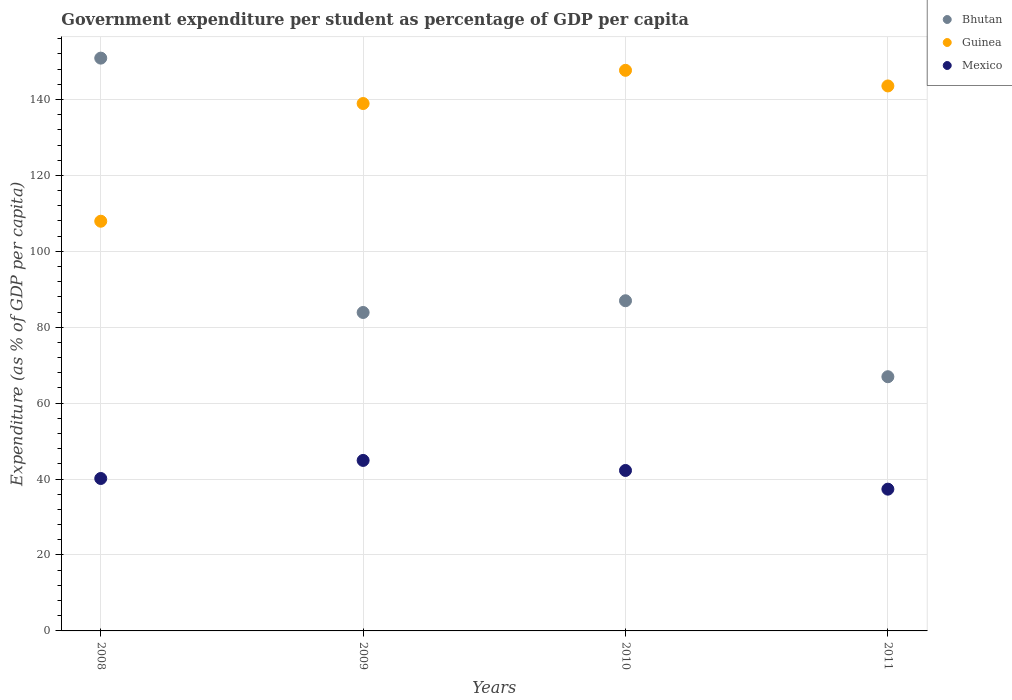How many different coloured dotlines are there?
Keep it short and to the point. 3. Is the number of dotlines equal to the number of legend labels?
Offer a very short reply. Yes. What is the percentage of expenditure per student in Mexico in 2009?
Your answer should be compact. 44.91. Across all years, what is the maximum percentage of expenditure per student in Mexico?
Offer a terse response. 44.91. Across all years, what is the minimum percentage of expenditure per student in Mexico?
Provide a short and direct response. 37.34. In which year was the percentage of expenditure per student in Mexico maximum?
Ensure brevity in your answer.  2009. In which year was the percentage of expenditure per student in Guinea minimum?
Your answer should be compact. 2008. What is the total percentage of expenditure per student in Mexico in the graph?
Keep it short and to the point. 164.68. What is the difference between the percentage of expenditure per student in Mexico in 2010 and that in 2011?
Your response must be concise. 4.92. What is the difference between the percentage of expenditure per student in Mexico in 2008 and the percentage of expenditure per student in Bhutan in 2009?
Keep it short and to the point. -43.73. What is the average percentage of expenditure per student in Bhutan per year?
Offer a very short reply. 97.18. In the year 2009, what is the difference between the percentage of expenditure per student in Bhutan and percentage of expenditure per student in Mexico?
Offer a terse response. 38.97. What is the ratio of the percentage of expenditure per student in Bhutan in 2009 to that in 2010?
Ensure brevity in your answer.  0.96. Is the difference between the percentage of expenditure per student in Bhutan in 2009 and 2010 greater than the difference between the percentage of expenditure per student in Mexico in 2009 and 2010?
Keep it short and to the point. No. What is the difference between the highest and the second highest percentage of expenditure per student in Bhutan?
Offer a terse response. 63.91. What is the difference between the highest and the lowest percentage of expenditure per student in Bhutan?
Offer a terse response. 83.93. Is the percentage of expenditure per student in Bhutan strictly greater than the percentage of expenditure per student in Guinea over the years?
Give a very brief answer. No. Is the percentage of expenditure per student in Bhutan strictly less than the percentage of expenditure per student in Guinea over the years?
Your answer should be very brief. No. How many years are there in the graph?
Your response must be concise. 4. What is the difference between two consecutive major ticks on the Y-axis?
Your response must be concise. 20. Are the values on the major ticks of Y-axis written in scientific E-notation?
Ensure brevity in your answer.  No. How are the legend labels stacked?
Make the answer very short. Vertical. What is the title of the graph?
Offer a terse response. Government expenditure per student as percentage of GDP per capita. Does "Sweden" appear as one of the legend labels in the graph?
Offer a terse response. No. What is the label or title of the X-axis?
Your answer should be very brief. Years. What is the label or title of the Y-axis?
Offer a very short reply. Expenditure (as % of GDP per capita). What is the Expenditure (as % of GDP per capita) in Bhutan in 2008?
Your response must be concise. 150.89. What is the Expenditure (as % of GDP per capita) of Guinea in 2008?
Offer a terse response. 107.93. What is the Expenditure (as % of GDP per capita) in Mexico in 2008?
Your answer should be very brief. 40.16. What is the Expenditure (as % of GDP per capita) in Bhutan in 2009?
Offer a very short reply. 83.89. What is the Expenditure (as % of GDP per capita) in Guinea in 2009?
Make the answer very short. 138.93. What is the Expenditure (as % of GDP per capita) in Mexico in 2009?
Offer a terse response. 44.91. What is the Expenditure (as % of GDP per capita) of Bhutan in 2010?
Offer a very short reply. 86.98. What is the Expenditure (as % of GDP per capita) of Guinea in 2010?
Offer a terse response. 147.68. What is the Expenditure (as % of GDP per capita) of Mexico in 2010?
Give a very brief answer. 42.27. What is the Expenditure (as % of GDP per capita) in Bhutan in 2011?
Keep it short and to the point. 66.96. What is the Expenditure (as % of GDP per capita) in Guinea in 2011?
Keep it short and to the point. 143.56. What is the Expenditure (as % of GDP per capita) in Mexico in 2011?
Give a very brief answer. 37.34. Across all years, what is the maximum Expenditure (as % of GDP per capita) of Bhutan?
Give a very brief answer. 150.89. Across all years, what is the maximum Expenditure (as % of GDP per capita) in Guinea?
Your answer should be very brief. 147.68. Across all years, what is the maximum Expenditure (as % of GDP per capita) of Mexico?
Your answer should be compact. 44.91. Across all years, what is the minimum Expenditure (as % of GDP per capita) of Bhutan?
Make the answer very short. 66.96. Across all years, what is the minimum Expenditure (as % of GDP per capita) in Guinea?
Your response must be concise. 107.93. Across all years, what is the minimum Expenditure (as % of GDP per capita) of Mexico?
Your response must be concise. 37.34. What is the total Expenditure (as % of GDP per capita) in Bhutan in the graph?
Give a very brief answer. 388.72. What is the total Expenditure (as % of GDP per capita) in Guinea in the graph?
Your response must be concise. 538.1. What is the total Expenditure (as % of GDP per capita) of Mexico in the graph?
Your response must be concise. 164.68. What is the difference between the Expenditure (as % of GDP per capita) in Bhutan in 2008 and that in 2009?
Your answer should be compact. 67. What is the difference between the Expenditure (as % of GDP per capita) of Guinea in 2008 and that in 2009?
Your answer should be very brief. -31.01. What is the difference between the Expenditure (as % of GDP per capita) of Mexico in 2008 and that in 2009?
Provide a succinct answer. -4.76. What is the difference between the Expenditure (as % of GDP per capita) of Bhutan in 2008 and that in 2010?
Ensure brevity in your answer.  63.91. What is the difference between the Expenditure (as % of GDP per capita) in Guinea in 2008 and that in 2010?
Your answer should be compact. -39.75. What is the difference between the Expenditure (as % of GDP per capita) of Mexico in 2008 and that in 2010?
Give a very brief answer. -2.11. What is the difference between the Expenditure (as % of GDP per capita) in Bhutan in 2008 and that in 2011?
Give a very brief answer. 83.93. What is the difference between the Expenditure (as % of GDP per capita) of Guinea in 2008 and that in 2011?
Offer a terse response. -35.64. What is the difference between the Expenditure (as % of GDP per capita) in Mexico in 2008 and that in 2011?
Make the answer very short. 2.81. What is the difference between the Expenditure (as % of GDP per capita) of Bhutan in 2009 and that in 2010?
Make the answer very short. -3.09. What is the difference between the Expenditure (as % of GDP per capita) in Guinea in 2009 and that in 2010?
Your answer should be compact. -8.74. What is the difference between the Expenditure (as % of GDP per capita) of Mexico in 2009 and that in 2010?
Your answer should be very brief. 2.65. What is the difference between the Expenditure (as % of GDP per capita) of Bhutan in 2009 and that in 2011?
Your answer should be very brief. 16.92. What is the difference between the Expenditure (as % of GDP per capita) in Guinea in 2009 and that in 2011?
Ensure brevity in your answer.  -4.63. What is the difference between the Expenditure (as % of GDP per capita) in Mexico in 2009 and that in 2011?
Your answer should be very brief. 7.57. What is the difference between the Expenditure (as % of GDP per capita) in Bhutan in 2010 and that in 2011?
Make the answer very short. 20.01. What is the difference between the Expenditure (as % of GDP per capita) in Guinea in 2010 and that in 2011?
Provide a succinct answer. 4.11. What is the difference between the Expenditure (as % of GDP per capita) of Mexico in 2010 and that in 2011?
Make the answer very short. 4.92. What is the difference between the Expenditure (as % of GDP per capita) in Bhutan in 2008 and the Expenditure (as % of GDP per capita) in Guinea in 2009?
Provide a short and direct response. 11.96. What is the difference between the Expenditure (as % of GDP per capita) of Bhutan in 2008 and the Expenditure (as % of GDP per capita) of Mexico in 2009?
Provide a succinct answer. 105.97. What is the difference between the Expenditure (as % of GDP per capita) of Guinea in 2008 and the Expenditure (as % of GDP per capita) of Mexico in 2009?
Give a very brief answer. 63.01. What is the difference between the Expenditure (as % of GDP per capita) of Bhutan in 2008 and the Expenditure (as % of GDP per capita) of Guinea in 2010?
Your answer should be compact. 3.21. What is the difference between the Expenditure (as % of GDP per capita) of Bhutan in 2008 and the Expenditure (as % of GDP per capita) of Mexico in 2010?
Offer a very short reply. 108.62. What is the difference between the Expenditure (as % of GDP per capita) of Guinea in 2008 and the Expenditure (as % of GDP per capita) of Mexico in 2010?
Give a very brief answer. 65.66. What is the difference between the Expenditure (as % of GDP per capita) in Bhutan in 2008 and the Expenditure (as % of GDP per capita) in Guinea in 2011?
Your response must be concise. 7.33. What is the difference between the Expenditure (as % of GDP per capita) in Bhutan in 2008 and the Expenditure (as % of GDP per capita) in Mexico in 2011?
Offer a terse response. 113.55. What is the difference between the Expenditure (as % of GDP per capita) in Guinea in 2008 and the Expenditure (as % of GDP per capita) in Mexico in 2011?
Your answer should be very brief. 70.58. What is the difference between the Expenditure (as % of GDP per capita) of Bhutan in 2009 and the Expenditure (as % of GDP per capita) of Guinea in 2010?
Your response must be concise. -63.79. What is the difference between the Expenditure (as % of GDP per capita) in Bhutan in 2009 and the Expenditure (as % of GDP per capita) in Mexico in 2010?
Your response must be concise. 41.62. What is the difference between the Expenditure (as % of GDP per capita) of Guinea in 2009 and the Expenditure (as % of GDP per capita) of Mexico in 2010?
Make the answer very short. 96.66. What is the difference between the Expenditure (as % of GDP per capita) of Bhutan in 2009 and the Expenditure (as % of GDP per capita) of Guinea in 2011?
Ensure brevity in your answer.  -59.68. What is the difference between the Expenditure (as % of GDP per capita) in Bhutan in 2009 and the Expenditure (as % of GDP per capita) in Mexico in 2011?
Provide a succinct answer. 46.54. What is the difference between the Expenditure (as % of GDP per capita) of Guinea in 2009 and the Expenditure (as % of GDP per capita) of Mexico in 2011?
Offer a very short reply. 101.59. What is the difference between the Expenditure (as % of GDP per capita) in Bhutan in 2010 and the Expenditure (as % of GDP per capita) in Guinea in 2011?
Provide a short and direct response. -56.59. What is the difference between the Expenditure (as % of GDP per capita) of Bhutan in 2010 and the Expenditure (as % of GDP per capita) of Mexico in 2011?
Give a very brief answer. 49.63. What is the difference between the Expenditure (as % of GDP per capita) in Guinea in 2010 and the Expenditure (as % of GDP per capita) in Mexico in 2011?
Give a very brief answer. 110.33. What is the average Expenditure (as % of GDP per capita) of Bhutan per year?
Offer a terse response. 97.18. What is the average Expenditure (as % of GDP per capita) in Guinea per year?
Make the answer very short. 134.52. What is the average Expenditure (as % of GDP per capita) in Mexico per year?
Provide a short and direct response. 41.17. In the year 2008, what is the difference between the Expenditure (as % of GDP per capita) in Bhutan and Expenditure (as % of GDP per capita) in Guinea?
Give a very brief answer. 42.96. In the year 2008, what is the difference between the Expenditure (as % of GDP per capita) in Bhutan and Expenditure (as % of GDP per capita) in Mexico?
Your response must be concise. 110.73. In the year 2008, what is the difference between the Expenditure (as % of GDP per capita) of Guinea and Expenditure (as % of GDP per capita) of Mexico?
Make the answer very short. 67.77. In the year 2009, what is the difference between the Expenditure (as % of GDP per capita) in Bhutan and Expenditure (as % of GDP per capita) in Guinea?
Ensure brevity in your answer.  -55.04. In the year 2009, what is the difference between the Expenditure (as % of GDP per capita) of Bhutan and Expenditure (as % of GDP per capita) of Mexico?
Give a very brief answer. 38.97. In the year 2009, what is the difference between the Expenditure (as % of GDP per capita) of Guinea and Expenditure (as % of GDP per capita) of Mexico?
Make the answer very short. 94.02. In the year 2010, what is the difference between the Expenditure (as % of GDP per capita) in Bhutan and Expenditure (as % of GDP per capita) in Guinea?
Your answer should be very brief. -60.7. In the year 2010, what is the difference between the Expenditure (as % of GDP per capita) of Bhutan and Expenditure (as % of GDP per capita) of Mexico?
Offer a very short reply. 44.71. In the year 2010, what is the difference between the Expenditure (as % of GDP per capita) in Guinea and Expenditure (as % of GDP per capita) in Mexico?
Offer a very short reply. 105.41. In the year 2011, what is the difference between the Expenditure (as % of GDP per capita) of Bhutan and Expenditure (as % of GDP per capita) of Guinea?
Provide a succinct answer. -76.6. In the year 2011, what is the difference between the Expenditure (as % of GDP per capita) of Bhutan and Expenditure (as % of GDP per capita) of Mexico?
Your response must be concise. 29.62. In the year 2011, what is the difference between the Expenditure (as % of GDP per capita) in Guinea and Expenditure (as % of GDP per capita) in Mexico?
Your answer should be very brief. 106.22. What is the ratio of the Expenditure (as % of GDP per capita) of Bhutan in 2008 to that in 2009?
Keep it short and to the point. 1.8. What is the ratio of the Expenditure (as % of GDP per capita) of Guinea in 2008 to that in 2009?
Make the answer very short. 0.78. What is the ratio of the Expenditure (as % of GDP per capita) in Mexico in 2008 to that in 2009?
Offer a very short reply. 0.89. What is the ratio of the Expenditure (as % of GDP per capita) of Bhutan in 2008 to that in 2010?
Offer a very short reply. 1.73. What is the ratio of the Expenditure (as % of GDP per capita) in Guinea in 2008 to that in 2010?
Your answer should be compact. 0.73. What is the ratio of the Expenditure (as % of GDP per capita) of Mexico in 2008 to that in 2010?
Provide a succinct answer. 0.95. What is the ratio of the Expenditure (as % of GDP per capita) in Bhutan in 2008 to that in 2011?
Provide a short and direct response. 2.25. What is the ratio of the Expenditure (as % of GDP per capita) of Guinea in 2008 to that in 2011?
Your response must be concise. 0.75. What is the ratio of the Expenditure (as % of GDP per capita) in Mexico in 2008 to that in 2011?
Keep it short and to the point. 1.08. What is the ratio of the Expenditure (as % of GDP per capita) of Bhutan in 2009 to that in 2010?
Keep it short and to the point. 0.96. What is the ratio of the Expenditure (as % of GDP per capita) of Guinea in 2009 to that in 2010?
Your answer should be compact. 0.94. What is the ratio of the Expenditure (as % of GDP per capita) of Mexico in 2009 to that in 2010?
Make the answer very short. 1.06. What is the ratio of the Expenditure (as % of GDP per capita) in Bhutan in 2009 to that in 2011?
Offer a terse response. 1.25. What is the ratio of the Expenditure (as % of GDP per capita) in Guinea in 2009 to that in 2011?
Provide a succinct answer. 0.97. What is the ratio of the Expenditure (as % of GDP per capita) of Mexico in 2009 to that in 2011?
Provide a succinct answer. 1.2. What is the ratio of the Expenditure (as % of GDP per capita) of Bhutan in 2010 to that in 2011?
Your response must be concise. 1.3. What is the ratio of the Expenditure (as % of GDP per capita) of Guinea in 2010 to that in 2011?
Your answer should be compact. 1.03. What is the ratio of the Expenditure (as % of GDP per capita) in Mexico in 2010 to that in 2011?
Keep it short and to the point. 1.13. What is the difference between the highest and the second highest Expenditure (as % of GDP per capita) in Bhutan?
Ensure brevity in your answer.  63.91. What is the difference between the highest and the second highest Expenditure (as % of GDP per capita) in Guinea?
Keep it short and to the point. 4.11. What is the difference between the highest and the second highest Expenditure (as % of GDP per capita) in Mexico?
Offer a very short reply. 2.65. What is the difference between the highest and the lowest Expenditure (as % of GDP per capita) of Bhutan?
Provide a short and direct response. 83.93. What is the difference between the highest and the lowest Expenditure (as % of GDP per capita) of Guinea?
Your response must be concise. 39.75. What is the difference between the highest and the lowest Expenditure (as % of GDP per capita) in Mexico?
Your answer should be very brief. 7.57. 